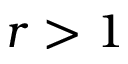Convert formula to latex. <formula><loc_0><loc_0><loc_500><loc_500>r > 1</formula> 